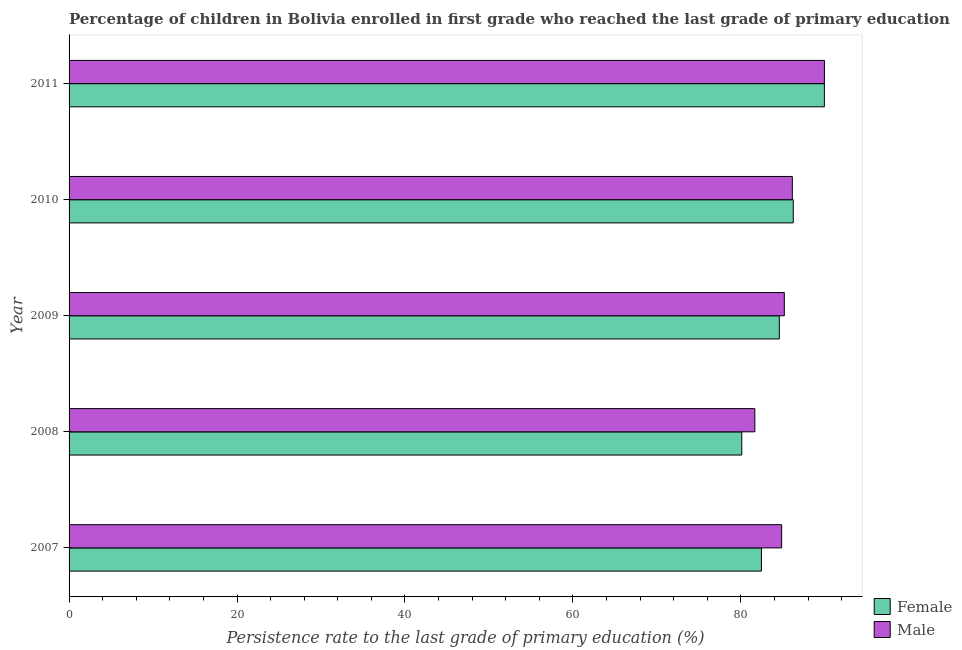How many groups of bars are there?
Provide a short and direct response. 5. Are the number of bars per tick equal to the number of legend labels?
Your answer should be compact. Yes. Are the number of bars on each tick of the Y-axis equal?
Provide a succinct answer. Yes. How many bars are there on the 5th tick from the bottom?
Offer a terse response. 2. What is the persistence rate of female students in 2009?
Provide a succinct answer. 84.58. Across all years, what is the maximum persistence rate of female students?
Your response must be concise. 89.94. Across all years, what is the minimum persistence rate of female students?
Give a very brief answer. 80.11. What is the total persistence rate of male students in the graph?
Provide a short and direct response. 427.77. What is the difference between the persistence rate of male students in 2007 and that in 2011?
Your answer should be compact. -5.1. What is the difference between the persistence rate of female students in 2009 and the persistence rate of male students in 2011?
Provide a succinct answer. -5.37. What is the average persistence rate of male students per year?
Your answer should be very brief. 85.55. In the year 2011, what is the difference between the persistence rate of female students and persistence rate of male students?
Your response must be concise. -0.01. What is the ratio of the persistence rate of female students in 2007 to that in 2008?
Your answer should be compact. 1.03. Is the difference between the persistence rate of female students in 2008 and 2009 greater than the difference between the persistence rate of male students in 2008 and 2009?
Your answer should be compact. No. What is the difference between the highest and the second highest persistence rate of male students?
Offer a terse response. 3.82. What is the difference between the highest and the lowest persistence rate of male students?
Give a very brief answer. 8.29. What does the 1st bar from the bottom in 2011 represents?
Offer a very short reply. Female. How many years are there in the graph?
Provide a succinct answer. 5. Does the graph contain any zero values?
Offer a terse response. No. How are the legend labels stacked?
Offer a very short reply. Vertical. What is the title of the graph?
Your answer should be compact. Percentage of children in Bolivia enrolled in first grade who reached the last grade of primary education. What is the label or title of the X-axis?
Offer a terse response. Persistence rate to the last grade of primary education (%). What is the label or title of the Y-axis?
Offer a terse response. Year. What is the Persistence rate to the last grade of primary education (%) in Female in 2007?
Provide a short and direct response. 82.45. What is the Persistence rate to the last grade of primary education (%) in Male in 2007?
Give a very brief answer. 84.85. What is the Persistence rate to the last grade of primary education (%) of Female in 2008?
Ensure brevity in your answer.  80.11. What is the Persistence rate to the last grade of primary education (%) of Male in 2008?
Ensure brevity in your answer.  81.66. What is the Persistence rate to the last grade of primary education (%) in Female in 2009?
Your answer should be very brief. 84.58. What is the Persistence rate to the last grade of primary education (%) in Male in 2009?
Provide a short and direct response. 85.17. What is the Persistence rate to the last grade of primary education (%) of Female in 2010?
Make the answer very short. 86.24. What is the Persistence rate to the last grade of primary education (%) of Male in 2010?
Give a very brief answer. 86.13. What is the Persistence rate to the last grade of primary education (%) of Female in 2011?
Ensure brevity in your answer.  89.94. What is the Persistence rate to the last grade of primary education (%) of Male in 2011?
Offer a very short reply. 89.95. Across all years, what is the maximum Persistence rate to the last grade of primary education (%) of Female?
Your response must be concise. 89.94. Across all years, what is the maximum Persistence rate to the last grade of primary education (%) in Male?
Keep it short and to the point. 89.95. Across all years, what is the minimum Persistence rate to the last grade of primary education (%) in Female?
Offer a very short reply. 80.11. Across all years, what is the minimum Persistence rate to the last grade of primary education (%) in Male?
Provide a short and direct response. 81.66. What is the total Persistence rate to the last grade of primary education (%) of Female in the graph?
Make the answer very short. 423.32. What is the total Persistence rate to the last grade of primary education (%) of Male in the graph?
Keep it short and to the point. 427.77. What is the difference between the Persistence rate to the last grade of primary education (%) in Female in 2007 and that in 2008?
Offer a very short reply. 2.34. What is the difference between the Persistence rate to the last grade of primary education (%) in Male in 2007 and that in 2008?
Ensure brevity in your answer.  3.19. What is the difference between the Persistence rate to the last grade of primary education (%) in Female in 2007 and that in 2009?
Keep it short and to the point. -2.13. What is the difference between the Persistence rate to the last grade of primary education (%) in Male in 2007 and that in 2009?
Your answer should be very brief. -0.32. What is the difference between the Persistence rate to the last grade of primary education (%) of Female in 2007 and that in 2010?
Your answer should be compact. -3.79. What is the difference between the Persistence rate to the last grade of primary education (%) of Male in 2007 and that in 2010?
Offer a terse response. -1.28. What is the difference between the Persistence rate to the last grade of primary education (%) in Female in 2007 and that in 2011?
Your response must be concise. -7.49. What is the difference between the Persistence rate to the last grade of primary education (%) of Male in 2007 and that in 2011?
Your answer should be very brief. -5.1. What is the difference between the Persistence rate to the last grade of primary education (%) of Female in 2008 and that in 2009?
Offer a very short reply. -4.47. What is the difference between the Persistence rate to the last grade of primary education (%) of Male in 2008 and that in 2009?
Give a very brief answer. -3.51. What is the difference between the Persistence rate to the last grade of primary education (%) in Female in 2008 and that in 2010?
Offer a very short reply. -6.13. What is the difference between the Persistence rate to the last grade of primary education (%) in Male in 2008 and that in 2010?
Provide a short and direct response. -4.47. What is the difference between the Persistence rate to the last grade of primary education (%) of Female in 2008 and that in 2011?
Your response must be concise. -9.84. What is the difference between the Persistence rate to the last grade of primary education (%) of Male in 2008 and that in 2011?
Keep it short and to the point. -8.29. What is the difference between the Persistence rate to the last grade of primary education (%) of Female in 2009 and that in 2010?
Your answer should be very brief. -1.66. What is the difference between the Persistence rate to the last grade of primary education (%) in Male in 2009 and that in 2010?
Ensure brevity in your answer.  -0.96. What is the difference between the Persistence rate to the last grade of primary education (%) of Female in 2009 and that in 2011?
Provide a short and direct response. -5.37. What is the difference between the Persistence rate to the last grade of primary education (%) of Male in 2009 and that in 2011?
Provide a succinct answer. -4.78. What is the difference between the Persistence rate to the last grade of primary education (%) in Female in 2010 and that in 2011?
Offer a very short reply. -3.7. What is the difference between the Persistence rate to the last grade of primary education (%) in Male in 2010 and that in 2011?
Your response must be concise. -3.82. What is the difference between the Persistence rate to the last grade of primary education (%) of Female in 2007 and the Persistence rate to the last grade of primary education (%) of Male in 2008?
Provide a short and direct response. 0.79. What is the difference between the Persistence rate to the last grade of primary education (%) in Female in 2007 and the Persistence rate to the last grade of primary education (%) in Male in 2009?
Ensure brevity in your answer.  -2.72. What is the difference between the Persistence rate to the last grade of primary education (%) in Female in 2007 and the Persistence rate to the last grade of primary education (%) in Male in 2010?
Keep it short and to the point. -3.68. What is the difference between the Persistence rate to the last grade of primary education (%) in Female in 2007 and the Persistence rate to the last grade of primary education (%) in Male in 2011?
Ensure brevity in your answer.  -7.5. What is the difference between the Persistence rate to the last grade of primary education (%) of Female in 2008 and the Persistence rate to the last grade of primary education (%) of Male in 2009?
Your answer should be compact. -5.07. What is the difference between the Persistence rate to the last grade of primary education (%) in Female in 2008 and the Persistence rate to the last grade of primary education (%) in Male in 2010?
Your response must be concise. -6.02. What is the difference between the Persistence rate to the last grade of primary education (%) of Female in 2008 and the Persistence rate to the last grade of primary education (%) of Male in 2011?
Give a very brief answer. -9.84. What is the difference between the Persistence rate to the last grade of primary education (%) in Female in 2009 and the Persistence rate to the last grade of primary education (%) in Male in 2010?
Give a very brief answer. -1.55. What is the difference between the Persistence rate to the last grade of primary education (%) of Female in 2009 and the Persistence rate to the last grade of primary education (%) of Male in 2011?
Your response must be concise. -5.37. What is the difference between the Persistence rate to the last grade of primary education (%) of Female in 2010 and the Persistence rate to the last grade of primary education (%) of Male in 2011?
Give a very brief answer. -3.71. What is the average Persistence rate to the last grade of primary education (%) in Female per year?
Your response must be concise. 84.66. What is the average Persistence rate to the last grade of primary education (%) in Male per year?
Make the answer very short. 85.55. In the year 2007, what is the difference between the Persistence rate to the last grade of primary education (%) in Female and Persistence rate to the last grade of primary education (%) in Male?
Your answer should be very brief. -2.4. In the year 2008, what is the difference between the Persistence rate to the last grade of primary education (%) in Female and Persistence rate to the last grade of primary education (%) in Male?
Offer a terse response. -1.56. In the year 2009, what is the difference between the Persistence rate to the last grade of primary education (%) in Female and Persistence rate to the last grade of primary education (%) in Male?
Offer a very short reply. -0.59. In the year 2010, what is the difference between the Persistence rate to the last grade of primary education (%) in Female and Persistence rate to the last grade of primary education (%) in Male?
Your answer should be very brief. 0.11. In the year 2011, what is the difference between the Persistence rate to the last grade of primary education (%) in Female and Persistence rate to the last grade of primary education (%) in Male?
Offer a very short reply. -0.01. What is the ratio of the Persistence rate to the last grade of primary education (%) in Female in 2007 to that in 2008?
Offer a very short reply. 1.03. What is the ratio of the Persistence rate to the last grade of primary education (%) of Male in 2007 to that in 2008?
Provide a short and direct response. 1.04. What is the ratio of the Persistence rate to the last grade of primary education (%) of Female in 2007 to that in 2009?
Your answer should be very brief. 0.97. What is the ratio of the Persistence rate to the last grade of primary education (%) in Male in 2007 to that in 2009?
Provide a short and direct response. 1. What is the ratio of the Persistence rate to the last grade of primary education (%) in Female in 2007 to that in 2010?
Your answer should be compact. 0.96. What is the ratio of the Persistence rate to the last grade of primary education (%) of Male in 2007 to that in 2010?
Your response must be concise. 0.99. What is the ratio of the Persistence rate to the last grade of primary education (%) of Female in 2007 to that in 2011?
Your answer should be compact. 0.92. What is the ratio of the Persistence rate to the last grade of primary education (%) of Male in 2007 to that in 2011?
Ensure brevity in your answer.  0.94. What is the ratio of the Persistence rate to the last grade of primary education (%) of Female in 2008 to that in 2009?
Provide a short and direct response. 0.95. What is the ratio of the Persistence rate to the last grade of primary education (%) in Male in 2008 to that in 2009?
Give a very brief answer. 0.96. What is the ratio of the Persistence rate to the last grade of primary education (%) in Female in 2008 to that in 2010?
Offer a terse response. 0.93. What is the ratio of the Persistence rate to the last grade of primary education (%) of Male in 2008 to that in 2010?
Your answer should be very brief. 0.95. What is the ratio of the Persistence rate to the last grade of primary education (%) of Female in 2008 to that in 2011?
Ensure brevity in your answer.  0.89. What is the ratio of the Persistence rate to the last grade of primary education (%) of Male in 2008 to that in 2011?
Give a very brief answer. 0.91. What is the ratio of the Persistence rate to the last grade of primary education (%) of Female in 2009 to that in 2010?
Offer a terse response. 0.98. What is the ratio of the Persistence rate to the last grade of primary education (%) of Male in 2009 to that in 2010?
Your response must be concise. 0.99. What is the ratio of the Persistence rate to the last grade of primary education (%) of Female in 2009 to that in 2011?
Ensure brevity in your answer.  0.94. What is the ratio of the Persistence rate to the last grade of primary education (%) in Male in 2009 to that in 2011?
Offer a very short reply. 0.95. What is the ratio of the Persistence rate to the last grade of primary education (%) of Female in 2010 to that in 2011?
Your response must be concise. 0.96. What is the ratio of the Persistence rate to the last grade of primary education (%) in Male in 2010 to that in 2011?
Your response must be concise. 0.96. What is the difference between the highest and the second highest Persistence rate to the last grade of primary education (%) in Female?
Provide a short and direct response. 3.7. What is the difference between the highest and the second highest Persistence rate to the last grade of primary education (%) of Male?
Make the answer very short. 3.82. What is the difference between the highest and the lowest Persistence rate to the last grade of primary education (%) of Female?
Your response must be concise. 9.84. What is the difference between the highest and the lowest Persistence rate to the last grade of primary education (%) of Male?
Offer a very short reply. 8.29. 